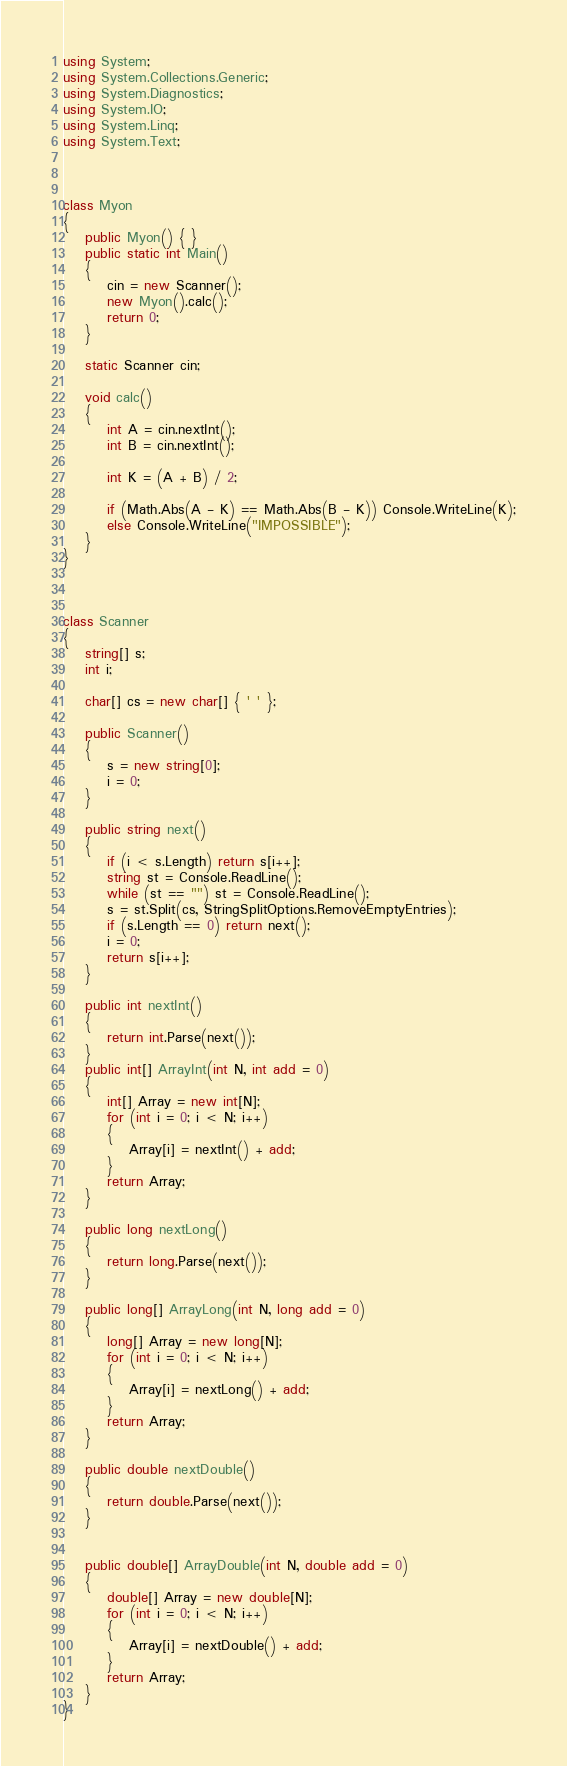<code> <loc_0><loc_0><loc_500><loc_500><_C#_>using System;
using System.Collections.Generic;
using System.Diagnostics;
using System.IO;
using System.Linq;
using System.Text;



class Myon
{
    public Myon() { }
    public static int Main()
    {
        cin = new Scanner();
        new Myon().calc();
        return 0;
    }

    static Scanner cin;

    void calc()
    {
        int A = cin.nextInt();
        int B = cin.nextInt();

        int K = (A + B) / 2;

        if (Math.Abs(A - K) == Math.Abs(B - K)) Console.WriteLine(K);
        else Console.WriteLine("IMPOSSIBLE");
    }
}



class Scanner
{
    string[] s;
    int i;

    char[] cs = new char[] { ' ' };

    public Scanner()
    {
        s = new string[0];
        i = 0;
    }

    public string next()
    {
        if (i < s.Length) return s[i++];
        string st = Console.ReadLine();
        while (st == "") st = Console.ReadLine();
        s = st.Split(cs, StringSplitOptions.RemoveEmptyEntries);
        if (s.Length == 0) return next();
        i = 0;
        return s[i++];
    }

    public int nextInt()
    {
        return int.Parse(next());
    }
    public int[] ArrayInt(int N, int add = 0)
    {
        int[] Array = new int[N];
        for (int i = 0; i < N; i++)
        {
            Array[i] = nextInt() + add;
        }
        return Array;
    }

    public long nextLong()
    {
        return long.Parse(next());
    }

    public long[] ArrayLong(int N, long add = 0)
    {
        long[] Array = new long[N];
        for (int i = 0; i < N; i++)
        {
            Array[i] = nextLong() + add;
        }
        return Array;
    }

    public double nextDouble()
    {
        return double.Parse(next());
    }


    public double[] ArrayDouble(int N, double add = 0)
    {
        double[] Array = new double[N];
        for (int i = 0; i < N; i++)
        {
            Array[i] = nextDouble() + add;
        }
        return Array;
    }
}
</code> 